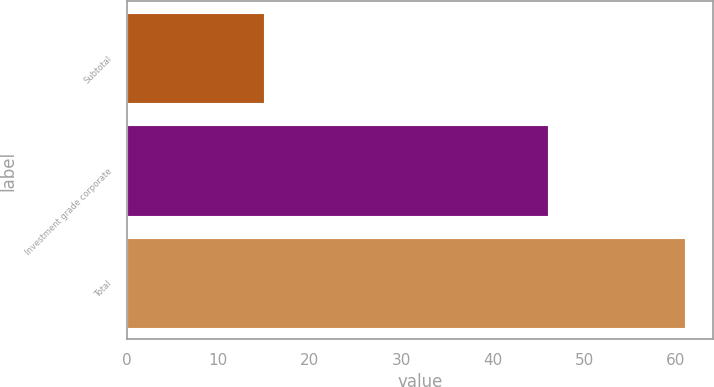Convert chart to OTSL. <chart><loc_0><loc_0><loc_500><loc_500><bar_chart><fcel>Subtotal<fcel>Investment grade corporate<fcel>Total<nl><fcel>15<fcel>46<fcel>61<nl></chart> 